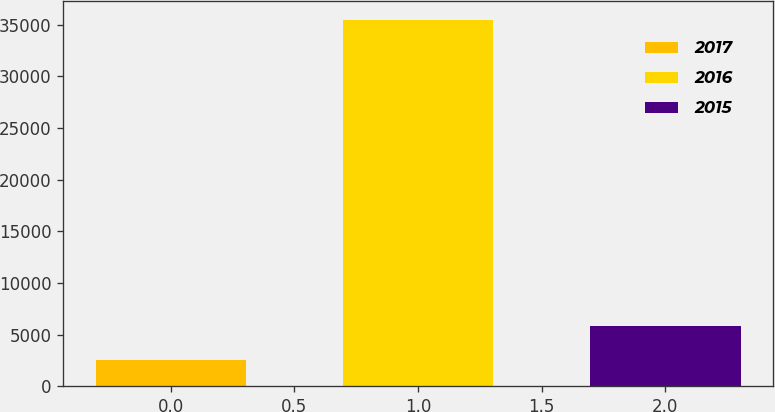<chart> <loc_0><loc_0><loc_500><loc_500><bar_chart><fcel>2017<fcel>2016<fcel>2015<nl><fcel>2548<fcel>35476<fcel>5840.8<nl></chart> 